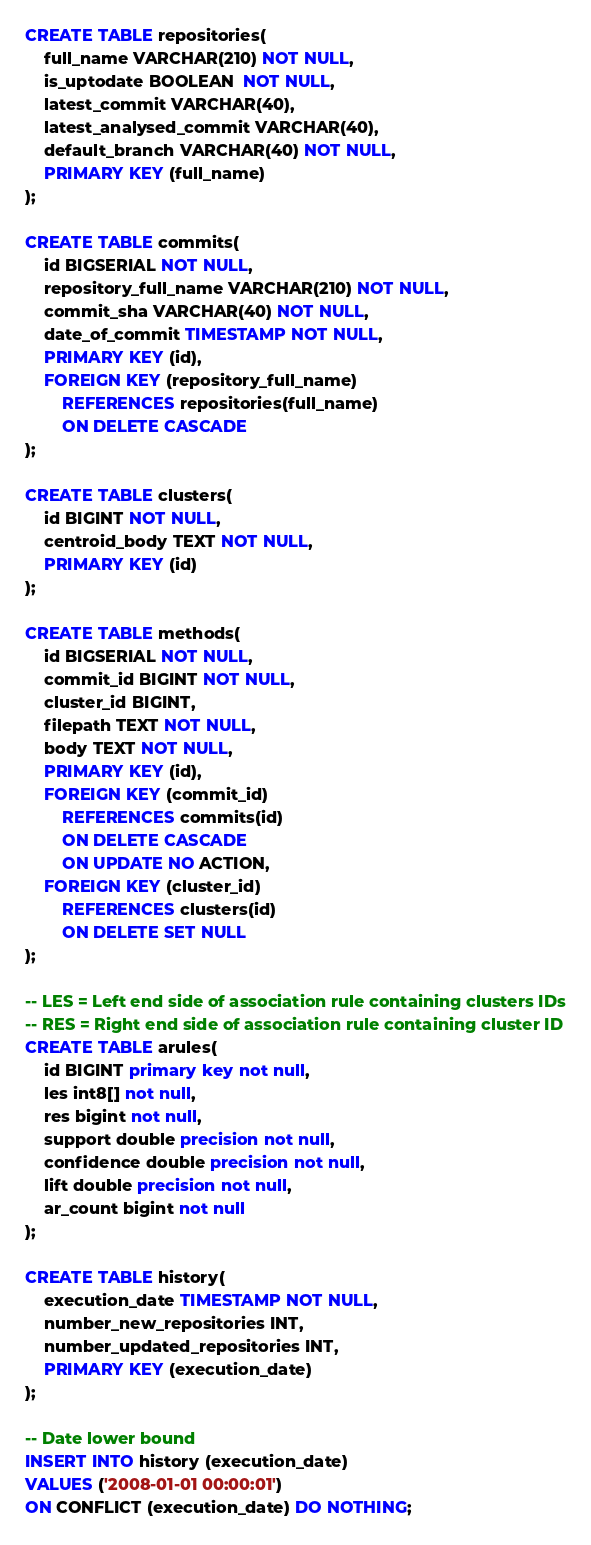<code> <loc_0><loc_0><loc_500><loc_500><_SQL_>
CREATE TABLE repositories(
    full_name VARCHAR(210) NOT NULL,
    is_uptodate BOOLEAN  NOT NULL,
    latest_commit VARCHAR(40),
    latest_analysed_commit VARCHAR(40),
    default_branch VARCHAR(40) NOT NULL,
    PRIMARY KEY (full_name)
);

CREATE TABLE commits(
	id BIGSERIAL NOT NULL,
    repository_full_name VARCHAR(210) NOT NULL,
    commit_sha VARCHAR(40) NOT NULL,
    date_of_commit TIMESTAMP NOT NULL,
    PRIMARY KEY (id),
    FOREIGN KEY (repository_full_name)
        REFERENCES repositories(full_name)
        ON DELETE CASCADE
);

CREATE TABLE clusters(
    id BIGINT NOT NULL,
    centroid_body TEXT NOT NULL,
    PRIMARY KEY (id)
);

CREATE TABLE methods(
    id BIGSERIAL NOT NULL,
    commit_id BIGINT NOT NULL,
    cluster_id BIGINT,
    filepath TEXT NOT NULL,
    body TEXT NOT NULL,
    PRIMARY KEY (id),
    FOREIGN KEY (commit_id)
        REFERENCES commits(id)
        ON DELETE CASCADE
        ON UPDATE NO ACTION,
    FOREIGN KEY (cluster_id)
        REFERENCES clusters(id)
        ON DELETE SET NULL
);

-- LES = Left end side of association rule containing clusters IDs
-- RES = Right end side of association rule containing cluster ID
CREATE TABLE arules(
    id BIGINT primary key not null,
    les int8[] not null,
    res bigint not null,
    support double precision not null,
    confidence double precision not null,
    lift double precision not null,
    ar_count bigint not null
);

CREATE TABLE history(
    execution_date TIMESTAMP NOT NULL,
    number_new_repositories INT,
    number_updated_repositories INT,
    PRIMARY KEY (execution_date)
);

-- Date lower bound
INSERT INTO history (execution_date)
VALUES ('2008-01-01 00:00:01') 
ON CONFLICT (execution_date) DO NOTHING;
</code> 